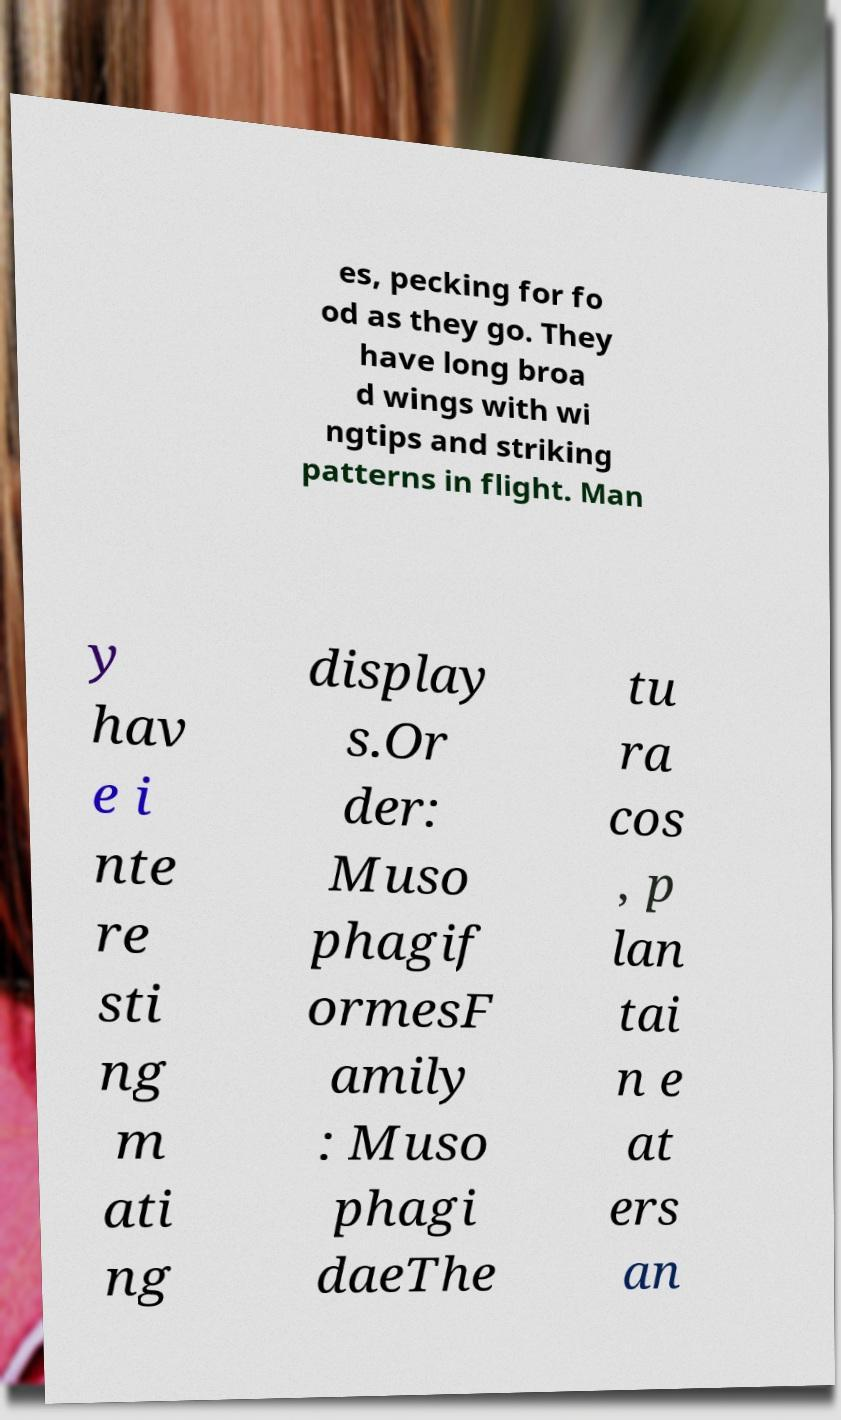Can you accurately transcribe the text from the provided image for me? es, pecking for fo od as they go. They have long broa d wings with wi ngtips and striking patterns in flight. Man y hav e i nte re sti ng m ati ng display s.Or der: Muso phagif ormesF amily : Muso phagi daeThe tu ra cos , p lan tai n e at ers an 